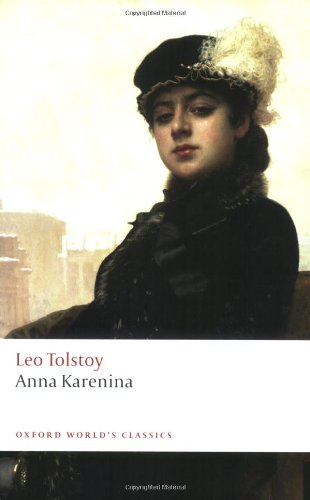How does the artwork on the cover relate to the themes of the book? The artwork on the cover features a woman in a contemplative mood wearing period attire, evoking the book's exploration of personal and societal struggles. This echoes the inner turmoil and the external societal expectations faced by the characters within the narrative, particularly the titular character, Anna. Can you tell more about the symbolism of her attire? Anna's attire, stylish and somewhat somber, symbolizes her social status and the elegance expected of her position, while also hinting at the personal sadness and confinement within her roles as a wife and a mother in a stringent society. The choice of colors and the style can signify mourning and constraint, reflecting her internal conflict. 